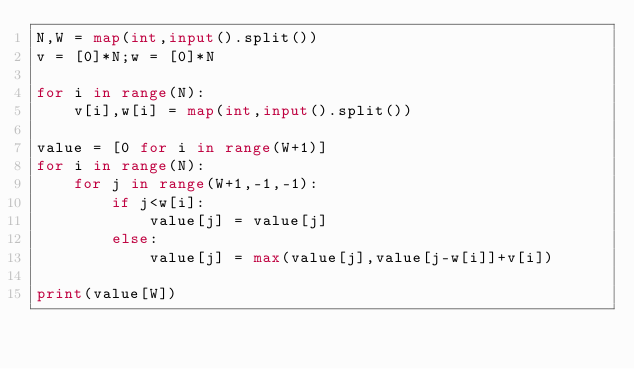<code> <loc_0><loc_0><loc_500><loc_500><_Python_>N,W = map(int,input().split())
v = [0]*N;w = [0]*N

for i in range(N):
    v[i],w[i] = map(int,input().split())

value = [0 for i in range(W+1)]
for i in range(N):
    for j in range(W+1,-1,-1):
        if j<w[i]:
            value[j] = value[j]
        else:
            value[j] = max(value[j],value[j-w[i]]+v[i])

print(value[W])</code> 